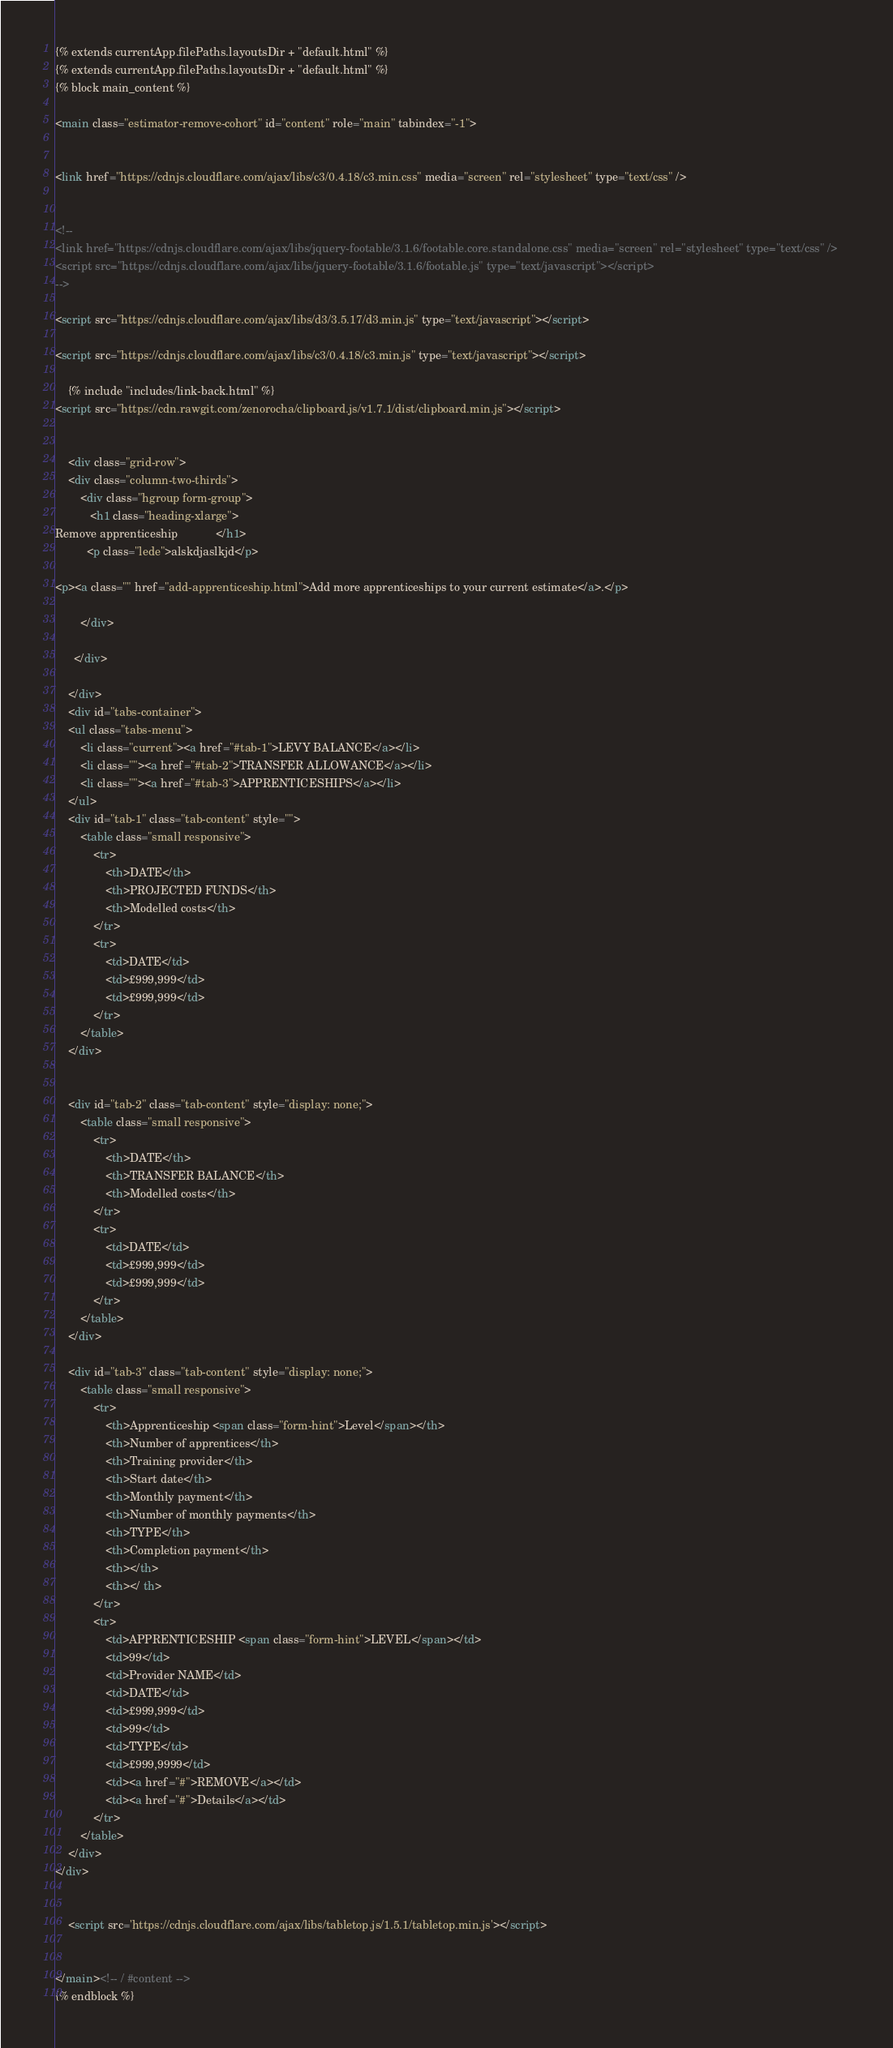Convert code to text. <code><loc_0><loc_0><loc_500><loc_500><_HTML_>{% extends currentApp.filePaths.layoutsDir + "default.html" %}
{% extends currentApp.filePaths.layoutsDir + "default.html" %}
{% block main_content %}

<main class="estimator-remove-cohort" id="content" role="main" tabindex="-1">
    

<link href="https://cdnjs.cloudflare.com/ajax/libs/c3/0.4.18/c3.min.css" media="screen" rel="stylesheet" type="text/css" />    


<!--
<link href="https://cdnjs.cloudflare.com/ajax/libs/jquery-footable/3.1.6/footable.core.standalone.css" media="screen" rel="stylesheet" type="text/css" />    
<script src="https://cdnjs.cloudflare.com/ajax/libs/jquery-footable/3.1.6/footable.js" type="text/javascript"></script>
-->

<script src="https://cdnjs.cloudflare.com/ajax/libs/d3/3.5.17/d3.min.js" type="text/javascript"></script>
    
<script src="https://cdnjs.cloudflare.com/ajax/libs/c3/0.4.18/c3.min.js" type="text/javascript"></script>
    
    {% include "includes/link-back.html" %}
<script src="https://cdn.rawgit.com/zenorocha/clipboard.js/v1.7.1/dist/clipboard.min.js"></script>

    
    <div class="grid-row">
    <div class="column-two-thirds">
        <div class="hgroup form-group">
           <h1 class="heading-xlarge">
Remove apprenticeship            </h1>
          <p class="lede">alskdjaslkjd</p> 

<p><a class="" href="add-apprenticeship.html">Add more apprenticeships to your current estimate</a>.</p>
 
        </div>
        
      </div>
       
    </div>
    <div id="tabs-container">
    <ul class="tabs-menu">
        <li class="current"><a href="#tab-1">LEVY BALANCE</a></li>
        <li class=""><a href="#tab-2">TRANSFER ALLOWANCE</a></li>
        <li class=""><a href="#tab-3">APPRENTICESHIPS</a></li>
    </ul>
    <div id="tab-1" class="tab-content" style="">
        <table class="small responsive">
            <tr>
                <th>DATE</th>
                <th>PROJECTED FUNDS</th>
                <th>Modelled costs</th>
            </tr>
            <tr>
                <td>DATE</td>
                <td>£999,999</td>
                <td>£999,999</td>
            </tr>
        </table>
    </div>


    <div id="tab-2" class="tab-content" style="display: none;">
        <table class="small responsive">
            <tr>
                <th>DATE</th>
                <th>TRANSFER BALANCE</th>
                <th>Modelled costs</th>
            </tr>
            <tr>
                <td>DATE</td>
                <td>£999,999</td>
                <td>£999,999</td>
            </tr>
        </table>
    </div>
        
    <div id="tab-3" class="tab-content" style="display: none;">
        <table class="small responsive">
            <tr>
                <th>Apprenticeship <span class="form-hint">Level</span></th>
                <th>Number of apprentices</th>
                <th>Training provider</th>
                <th>Start date</th>
                <th>Monthly payment</th>
                <th>Number of monthly payments</th>
                <th>TYPE</th>
                <th>Completion payment</th>
                <th></th>
                <th></ th>
            </tr>
            <tr>
                <td>APPRENTICESHIP <span class="form-hint">LEVEL</span></td>
                <td>99</td>
                <td>Provider NAME</td>
                <td>DATE</td>
                <td>£999,999</td>
                <td>99</td>
                <td>TYPE</td>
                <td>£999,9999</td>
                <td><a href="#">REMOVE</a></td>
                <td><a href="#">Details</a></td>
            </tr>
        </table>
    </div>
</div>                
         

    <script src='https://cdnjs.cloudflare.com/ajax/libs/tabletop.js/1.5.1/tabletop.min.js'></script>


</main><!-- / #content -->
{% endblock %}</code> 